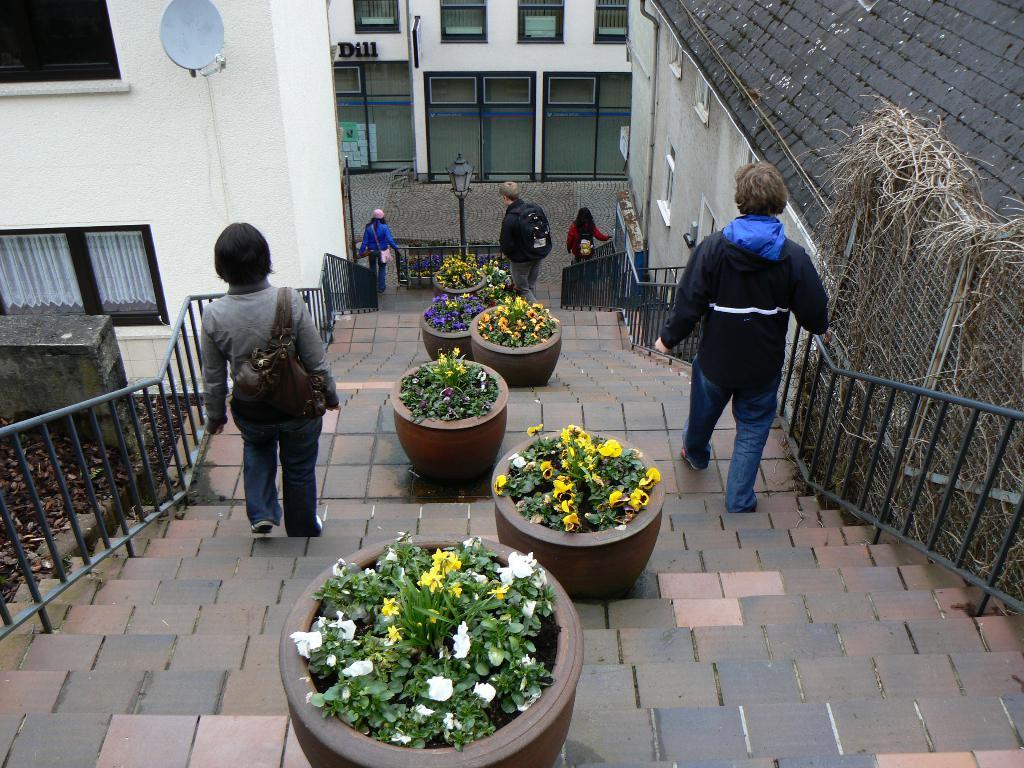In one or two sentences, can you explain what this image depicts? In the image at the bottom there are steps. In the middle of the steps there are pots with plants and flowers and also there are few people walking on the steps. At the sides of the steps there is a railing. In the background there are houses with walls, glass windows and poles with lamps. 